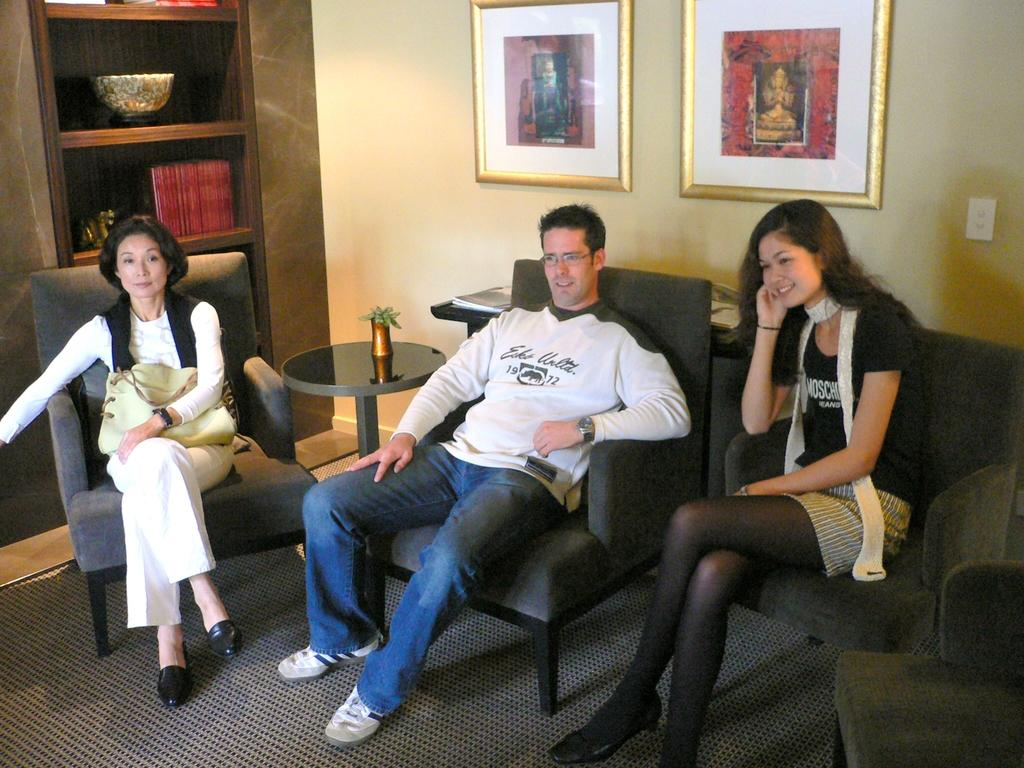How many people are in the image? There are three individuals in the image: two women and a man. What are the three individuals doing in the image? They are sitting in chairs and watching something in a living room. What type of knot is the man tying in the image? There is no knot or tying activity present in the image; the individuals are sitting and watching something. 